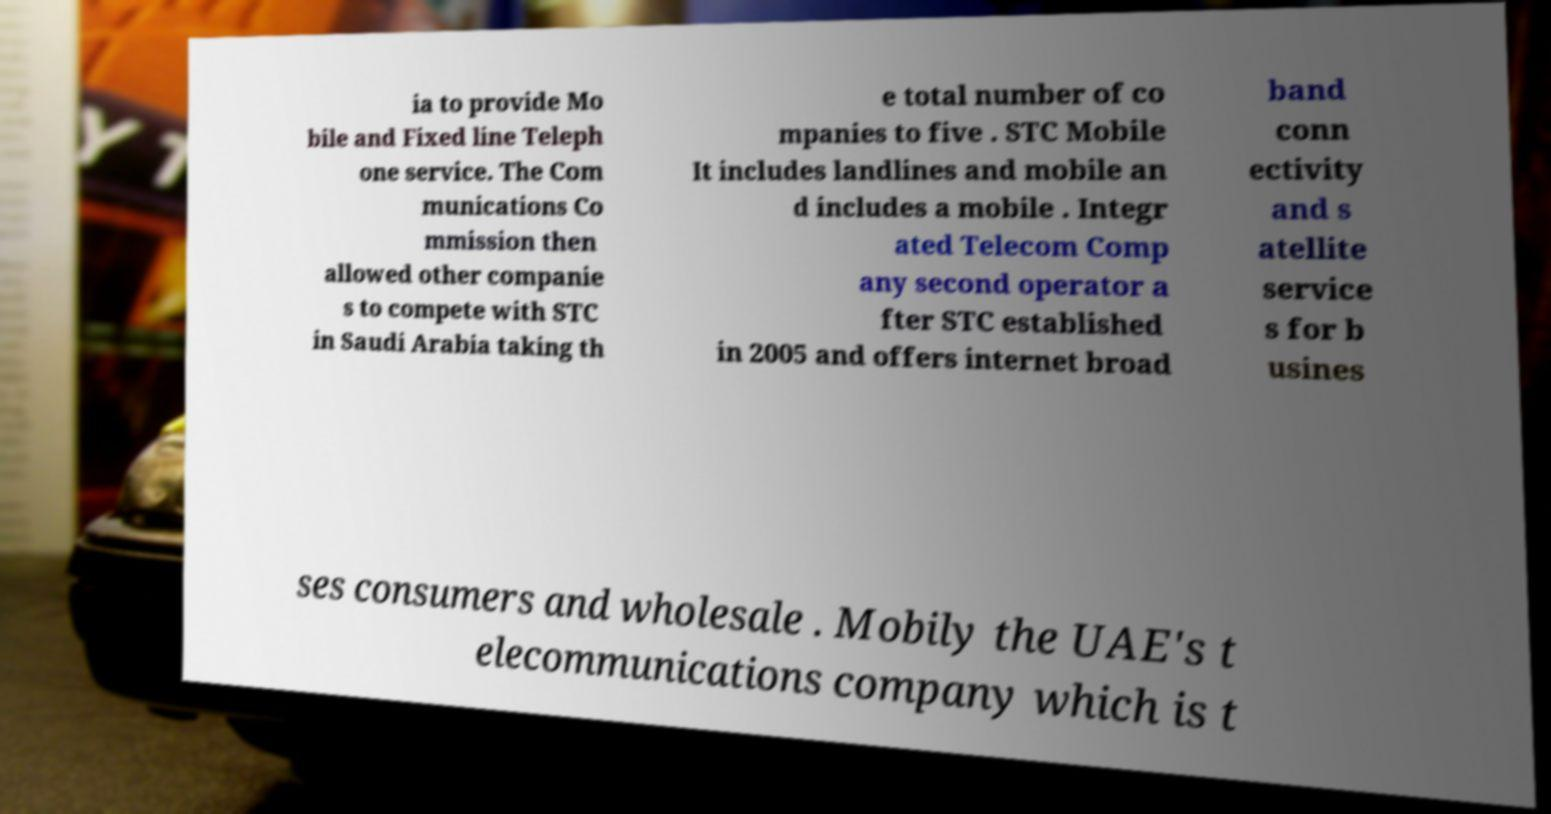Can you accurately transcribe the text from the provided image for me? ia to provide Mo bile and Fixed line Teleph one service. The Com munications Co mmission then allowed other companie s to compete with STC in Saudi Arabia taking th e total number of co mpanies to five . STC Mobile It includes landlines and mobile an d includes a mobile . Integr ated Telecom Comp any second operator a fter STC established in 2005 and offers internet broad band conn ectivity and s atellite service s for b usines ses consumers and wholesale . Mobily the UAE's t elecommunications company which is t 